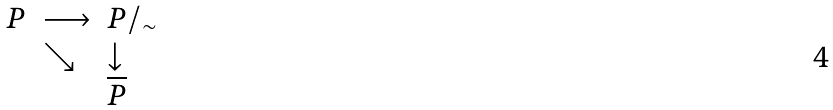<formula> <loc_0><loc_0><loc_500><loc_500>\begin{array} { c l l } P & \longrightarrow & P / _ { \sim } \\ & \searrow & \downarrow \\ & & \overline { P } \\ \end{array}</formula> 